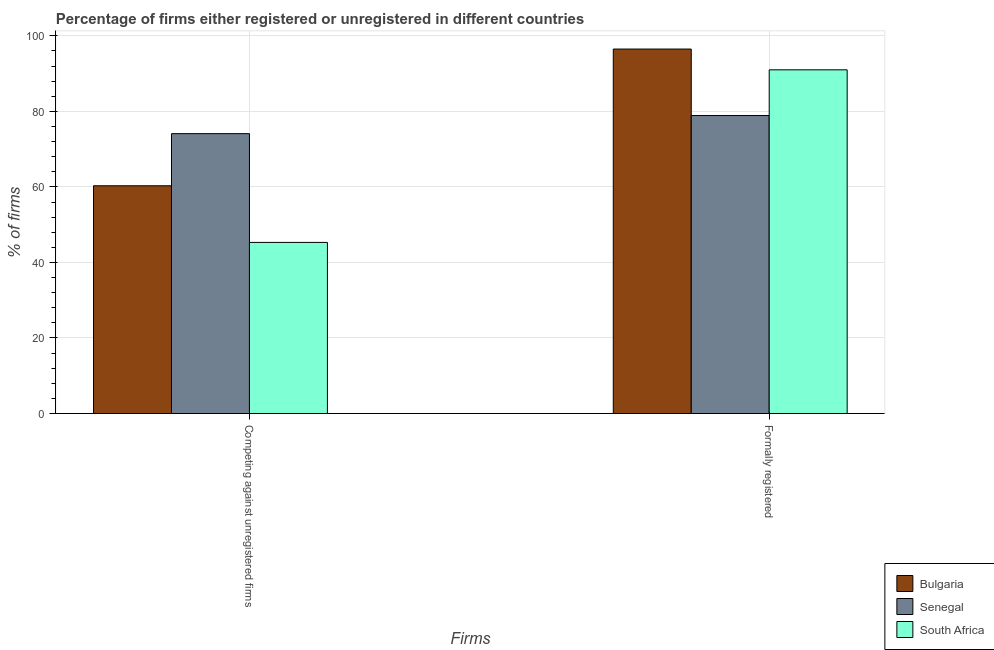How many bars are there on the 2nd tick from the left?
Your answer should be compact. 3. What is the label of the 2nd group of bars from the left?
Provide a short and direct response. Formally registered. What is the percentage of registered firms in Bulgaria?
Provide a succinct answer. 60.3. Across all countries, what is the maximum percentage of registered firms?
Ensure brevity in your answer.  74.1. Across all countries, what is the minimum percentage of registered firms?
Give a very brief answer. 45.3. In which country was the percentage of registered firms maximum?
Offer a terse response. Senegal. In which country was the percentage of formally registered firms minimum?
Your response must be concise. Senegal. What is the total percentage of registered firms in the graph?
Your answer should be very brief. 179.7. What is the difference between the percentage of registered firms in South Africa and that in Senegal?
Your response must be concise. -28.8. What is the difference between the percentage of formally registered firms in South Africa and the percentage of registered firms in Bulgaria?
Give a very brief answer. 30.7. What is the average percentage of registered firms per country?
Your response must be concise. 59.9. What is the difference between the percentage of formally registered firms and percentage of registered firms in Senegal?
Your answer should be compact. 4.8. What is the ratio of the percentage of registered firms in Senegal to that in South Africa?
Your response must be concise. 1.64. Is the percentage of formally registered firms in South Africa less than that in Bulgaria?
Your answer should be compact. Yes. What does the 3rd bar from the left in Competing against unregistered firms represents?
Make the answer very short. South Africa. What does the 1st bar from the right in Formally registered represents?
Provide a short and direct response. South Africa. How many bars are there?
Offer a very short reply. 6. Are all the bars in the graph horizontal?
Offer a terse response. No. How many countries are there in the graph?
Your response must be concise. 3. What is the difference between two consecutive major ticks on the Y-axis?
Give a very brief answer. 20. Are the values on the major ticks of Y-axis written in scientific E-notation?
Keep it short and to the point. No. Does the graph contain grids?
Make the answer very short. Yes. How many legend labels are there?
Your answer should be compact. 3. How are the legend labels stacked?
Give a very brief answer. Vertical. What is the title of the graph?
Ensure brevity in your answer.  Percentage of firms either registered or unregistered in different countries. Does "Togo" appear as one of the legend labels in the graph?
Give a very brief answer. No. What is the label or title of the X-axis?
Offer a terse response. Firms. What is the label or title of the Y-axis?
Provide a succinct answer. % of firms. What is the % of firms in Bulgaria in Competing against unregistered firms?
Your answer should be compact. 60.3. What is the % of firms in Senegal in Competing against unregistered firms?
Your answer should be compact. 74.1. What is the % of firms of South Africa in Competing against unregistered firms?
Offer a terse response. 45.3. What is the % of firms of Bulgaria in Formally registered?
Make the answer very short. 96.5. What is the % of firms of Senegal in Formally registered?
Your answer should be compact. 78.9. What is the % of firms in South Africa in Formally registered?
Make the answer very short. 91. Across all Firms, what is the maximum % of firms in Bulgaria?
Your response must be concise. 96.5. Across all Firms, what is the maximum % of firms in Senegal?
Keep it short and to the point. 78.9. Across all Firms, what is the maximum % of firms of South Africa?
Provide a succinct answer. 91. Across all Firms, what is the minimum % of firms of Bulgaria?
Your answer should be compact. 60.3. Across all Firms, what is the minimum % of firms of Senegal?
Provide a succinct answer. 74.1. Across all Firms, what is the minimum % of firms of South Africa?
Your response must be concise. 45.3. What is the total % of firms in Bulgaria in the graph?
Ensure brevity in your answer.  156.8. What is the total % of firms of Senegal in the graph?
Offer a very short reply. 153. What is the total % of firms in South Africa in the graph?
Keep it short and to the point. 136.3. What is the difference between the % of firms in Bulgaria in Competing against unregistered firms and that in Formally registered?
Provide a short and direct response. -36.2. What is the difference between the % of firms in South Africa in Competing against unregistered firms and that in Formally registered?
Ensure brevity in your answer.  -45.7. What is the difference between the % of firms in Bulgaria in Competing against unregistered firms and the % of firms in Senegal in Formally registered?
Offer a very short reply. -18.6. What is the difference between the % of firms of Bulgaria in Competing against unregistered firms and the % of firms of South Africa in Formally registered?
Make the answer very short. -30.7. What is the difference between the % of firms of Senegal in Competing against unregistered firms and the % of firms of South Africa in Formally registered?
Make the answer very short. -16.9. What is the average % of firms in Bulgaria per Firms?
Make the answer very short. 78.4. What is the average % of firms in Senegal per Firms?
Give a very brief answer. 76.5. What is the average % of firms of South Africa per Firms?
Your answer should be very brief. 68.15. What is the difference between the % of firms in Bulgaria and % of firms in Senegal in Competing against unregistered firms?
Give a very brief answer. -13.8. What is the difference between the % of firms in Bulgaria and % of firms in South Africa in Competing against unregistered firms?
Provide a short and direct response. 15. What is the difference between the % of firms in Senegal and % of firms in South Africa in Competing against unregistered firms?
Make the answer very short. 28.8. What is the difference between the % of firms in Bulgaria and % of firms in Senegal in Formally registered?
Your answer should be very brief. 17.6. What is the ratio of the % of firms in Bulgaria in Competing against unregistered firms to that in Formally registered?
Make the answer very short. 0.62. What is the ratio of the % of firms in Senegal in Competing against unregistered firms to that in Formally registered?
Make the answer very short. 0.94. What is the ratio of the % of firms in South Africa in Competing against unregistered firms to that in Formally registered?
Provide a short and direct response. 0.5. What is the difference between the highest and the second highest % of firms in Bulgaria?
Your answer should be very brief. 36.2. What is the difference between the highest and the second highest % of firms in Senegal?
Ensure brevity in your answer.  4.8. What is the difference between the highest and the second highest % of firms in South Africa?
Offer a very short reply. 45.7. What is the difference between the highest and the lowest % of firms of Bulgaria?
Provide a short and direct response. 36.2. What is the difference between the highest and the lowest % of firms of Senegal?
Ensure brevity in your answer.  4.8. What is the difference between the highest and the lowest % of firms in South Africa?
Offer a very short reply. 45.7. 